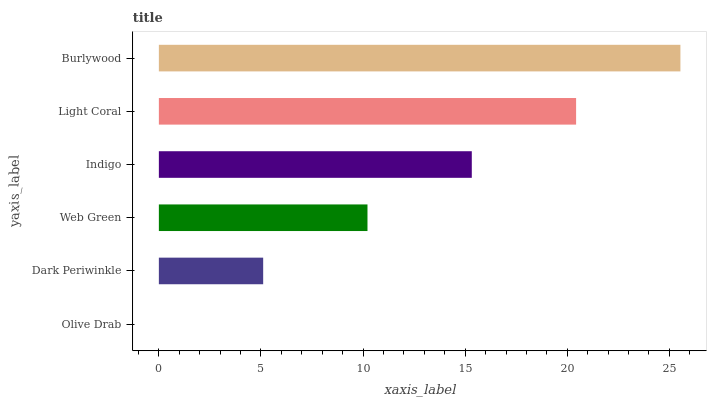Is Olive Drab the minimum?
Answer yes or no. Yes. Is Burlywood the maximum?
Answer yes or no. Yes. Is Dark Periwinkle the minimum?
Answer yes or no. No. Is Dark Periwinkle the maximum?
Answer yes or no. No. Is Dark Periwinkle greater than Olive Drab?
Answer yes or no. Yes. Is Olive Drab less than Dark Periwinkle?
Answer yes or no. Yes. Is Olive Drab greater than Dark Periwinkle?
Answer yes or no. No. Is Dark Periwinkle less than Olive Drab?
Answer yes or no. No. Is Indigo the high median?
Answer yes or no. Yes. Is Web Green the low median?
Answer yes or no. Yes. Is Light Coral the high median?
Answer yes or no. No. Is Dark Periwinkle the low median?
Answer yes or no. No. 